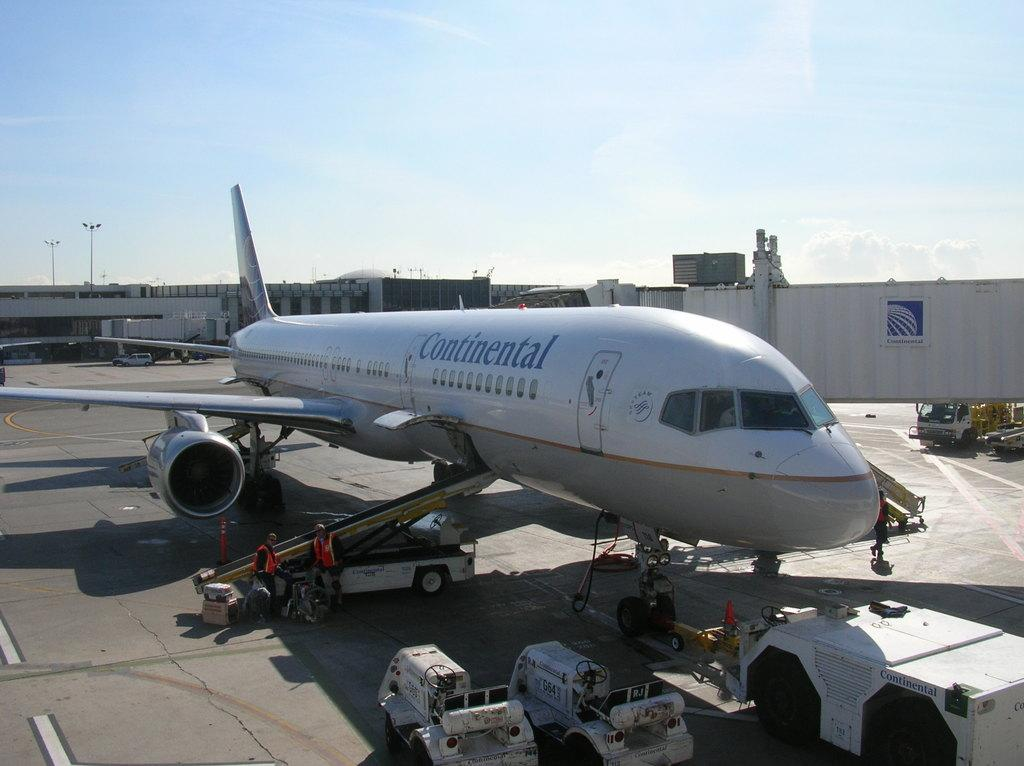<image>
Relay a brief, clear account of the picture shown. the word continental is on the white plane 